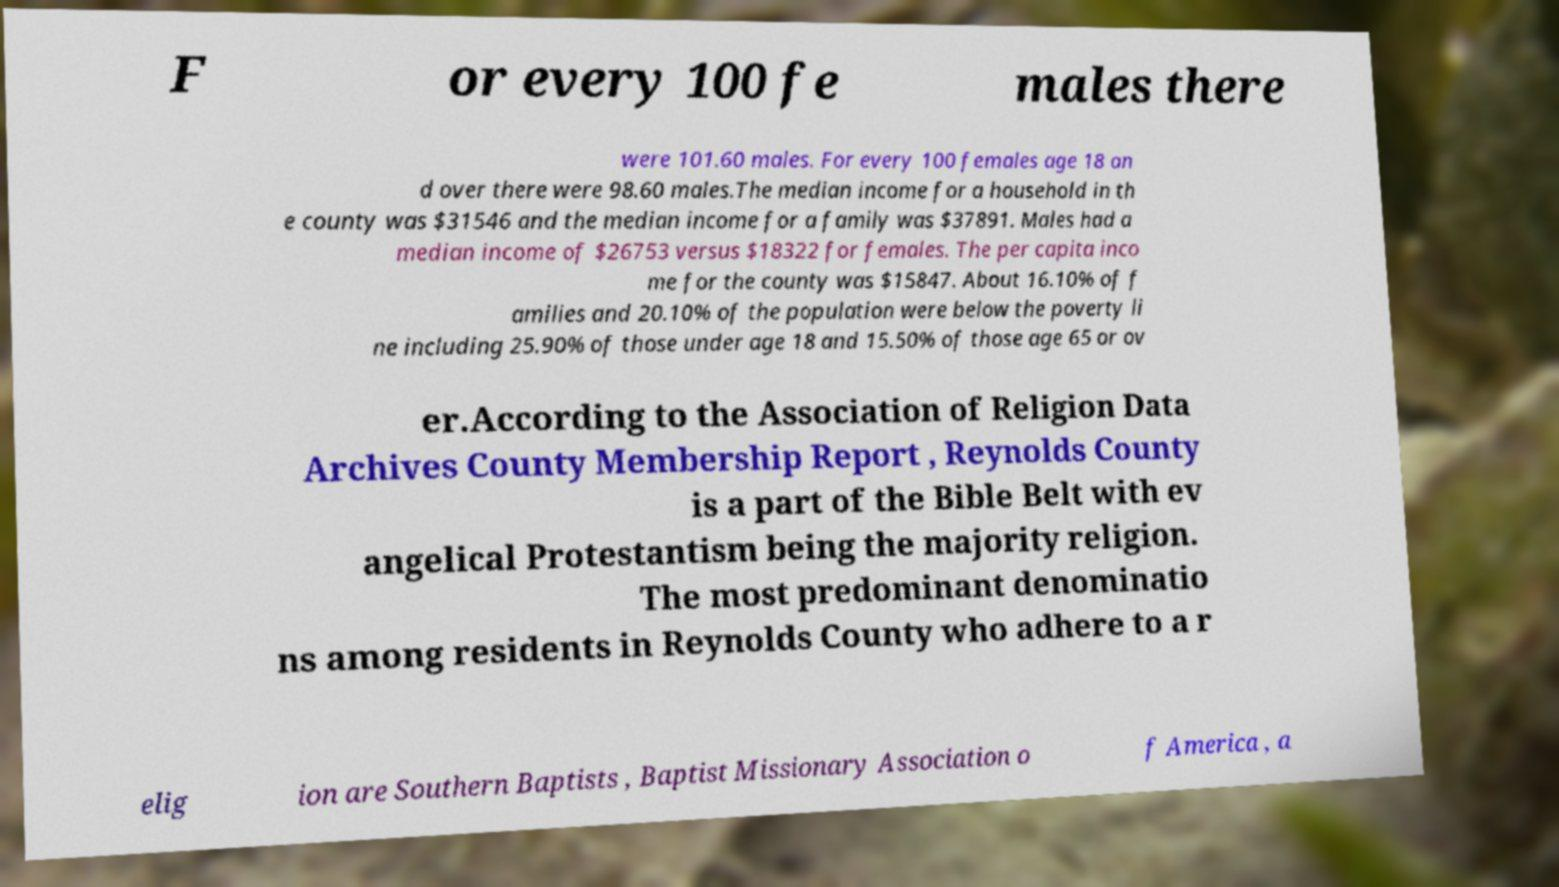Please identify and transcribe the text found in this image. F or every 100 fe males there were 101.60 males. For every 100 females age 18 an d over there were 98.60 males.The median income for a household in th e county was $31546 and the median income for a family was $37891. Males had a median income of $26753 versus $18322 for females. The per capita inco me for the county was $15847. About 16.10% of f amilies and 20.10% of the population were below the poverty li ne including 25.90% of those under age 18 and 15.50% of those age 65 or ov er.According to the Association of Religion Data Archives County Membership Report , Reynolds County is a part of the Bible Belt with ev angelical Protestantism being the majority religion. The most predominant denominatio ns among residents in Reynolds County who adhere to a r elig ion are Southern Baptists , Baptist Missionary Association o f America , a 